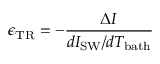<formula> <loc_0><loc_0><loc_500><loc_500>\epsilon _ { T R } = - \frac { \Delta I } { d I _ { S W } / d T _ { b a t h } }</formula> 